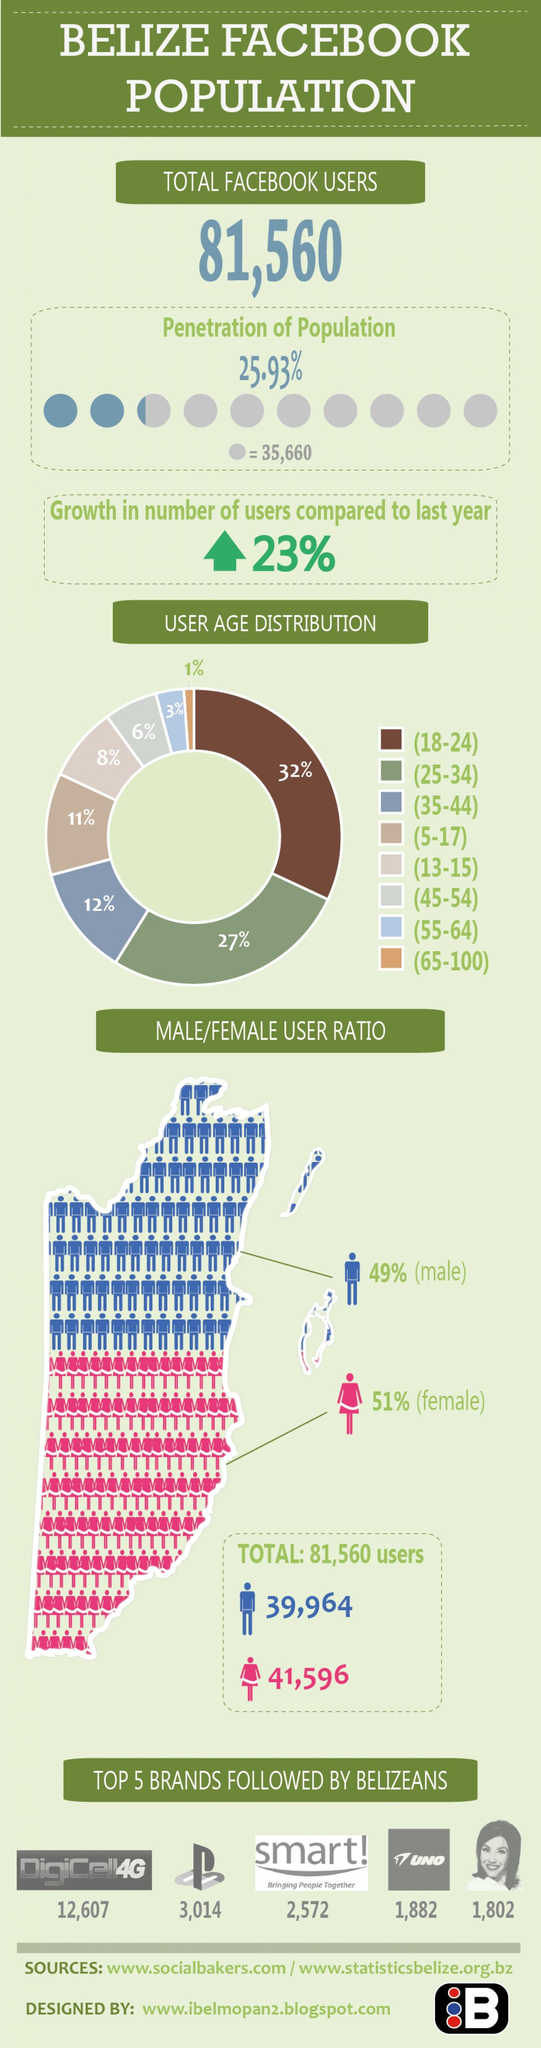Outline some significant characteristics in this image. In total, 39% of users fall within the age groups of 25-34 and 35-44. In total, 17% of users fall within the age groups of 5-17 and 45-54. 